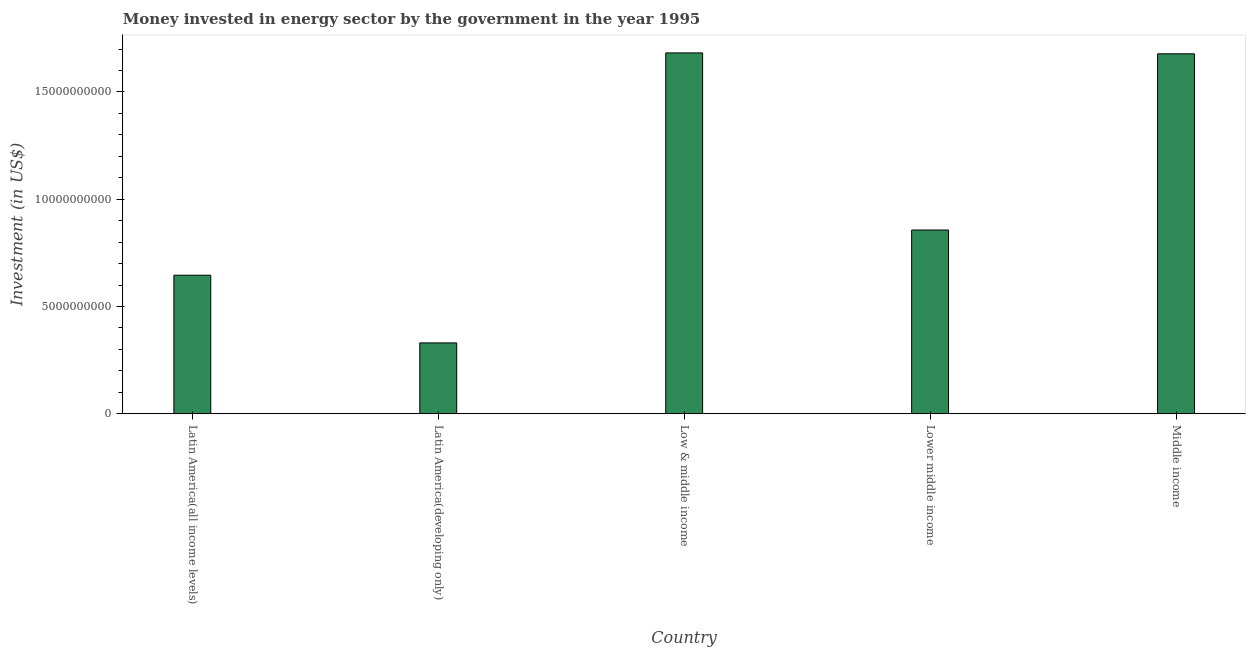Does the graph contain grids?
Offer a very short reply. No. What is the title of the graph?
Ensure brevity in your answer.  Money invested in energy sector by the government in the year 1995. What is the label or title of the X-axis?
Offer a very short reply. Country. What is the label or title of the Y-axis?
Your answer should be compact. Investment (in US$). What is the investment in energy in Latin America(developing only)?
Your answer should be very brief. 3.30e+09. Across all countries, what is the maximum investment in energy?
Offer a terse response. 1.68e+1. Across all countries, what is the minimum investment in energy?
Ensure brevity in your answer.  3.30e+09. In which country was the investment in energy maximum?
Provide a short and direct response. Low & middle income. In which country was the investment in energy minimum?
Provide a succinct answer. Latin America(developing only). What is the sum of the investment in energy?
Give a very brief answer. 5.19e+1. What is the difference between the investment in energy in Latin America(developing only) and Lower middle income?
Keep it short and to the point. -5.26e+09. What is the average investment in energy per country?
Your answer should be very brief. 1.04e+1. What is the median investment in energy?
Offer a terse response. 8.56e+09. In how many countries, is the investment in energy greater than 10000000000 US$?
Give a very brief answer. 2. What is the ratio of the investment in energy in Lower middle income to that in Middle income?
Your response must be concise. 0.51. Is the investment in energy in Lower middle income less than that in Middle income?
Provide a short and direct response. Yes. Is the difference between the investment in energy in Latin America(developing only) and Lower middle income greater than the difference between any two countries?
Your answer should be very brief. No. What is the difference between the highest and the second highest investment in energy?
Offer a terse response. 4.11e+07. Is the sum of the investment in energy in Latin America(all income levels) and Latin America(developing only) greater than the maximum investment in energy across all countries?
Your answer should be very brief. No. What is the difference between the highest and the lowest investment in energy?
Ensure brevity in your answer.  1.35e+1. How many countries are there in the graph?
Ensure brevity in your answer.  5. What is the Investment (in US$) of Latin America(all income levels)?
Your response must be concise. 6.46e+09. What is the Investment (in US$) of Latin America(developing only)?
Give a very brief answer. 3.30e+09. What is the Investment (in US$) in Low & middle income?
Ensure brevity in your answer.  1.68e+1. What is the Investment (in US$) of Lower middle income?
Keep it short and to the point. 8.56e+09. What is the Investment (in US$) of Middle income?
Provide a short and direct response. 1.68e+1. What is the difference between the Investment (in US$) in Latin America(all income levels) and Latin America(developing only)?
Make the answer very short. 3.16e+09. What is the difference between the Investment (in US$) in Latin America(all income levels) and Low & middle income?
Keep it short and to the point. -1.04e+1. What is the difference between the Investment (in US$) in Latin America(all income levels) and Lower middle income?
Provide a short and direct response. -2.11e+09. What is the difference between the Investment (in US$) in Latin America(all income levels) and Middle income?
Provide a succinct answer. -1.03e+1. What is the difference between the Investment (in US$) in Latin America(developing only) and Low & middle income?
Offer a terse response. -1.35e+1. What is the difference between the Investment (in US$) in Latin America(developing only) and Lower middle income?
Your answer should be very brief. -5.26e+09. What is the difference between the Investment (in US$) in Latin America(developing only) and Middle income?
Your answer should be very brief. -1.35e+1. What is the difference between the Investment (in US$) in Low & middle income and Lower middle income?
Your response must be concise. 8.25e+09. What is the difference between the Investment (in US$) in Low & middle income and Middle income?
Provide a short and direct response. 4.11e+07. What is the difference between the Investment (in US$) in Lower middle income and Middle income?
Keep it short and to the point. -8.21e+09. What is the ratio of the Investment (in US$) in Latin America(all income levels) to that in Latin America(developing only)?
Make the answer very short. 1.96. What is the ratio of the Investment (in US$) in Latin America(all income levels) to that in Low & middle income?
Your answer should be compact. 0.38. What is the ratio of the Investment (in US$) in Latin America(all income levels) to that in Lower middle income?
Offer a terse response. 0.75. What is the ratio of the Investment (in US$) in Latin America(all income levels) to that in Middle income?
Your answer should be very brief. 0.39. What is the ratio of the Investment (in US$) in Latin America(developing only) to that in Low & middle income?
Your response must be concise. 0.2. What is the ratio of the Investment (in US$) in Latin America(developing only) to that in Lower middle income?
Keep it short and to the point. 0.39. What is the ratio of the Investment (in US$) in Latin America(developing only) to that in Middle income?
Make the answer very short. 0.2. What is the ratio of the Investment (in US$) in Low & middle income to that in Lower middle income?
Make the answer very short. 1.96. What is the ratio of the Investment (in US$) in Lower middle income to that in Middle income?
Make the answer very short. 0.51. 